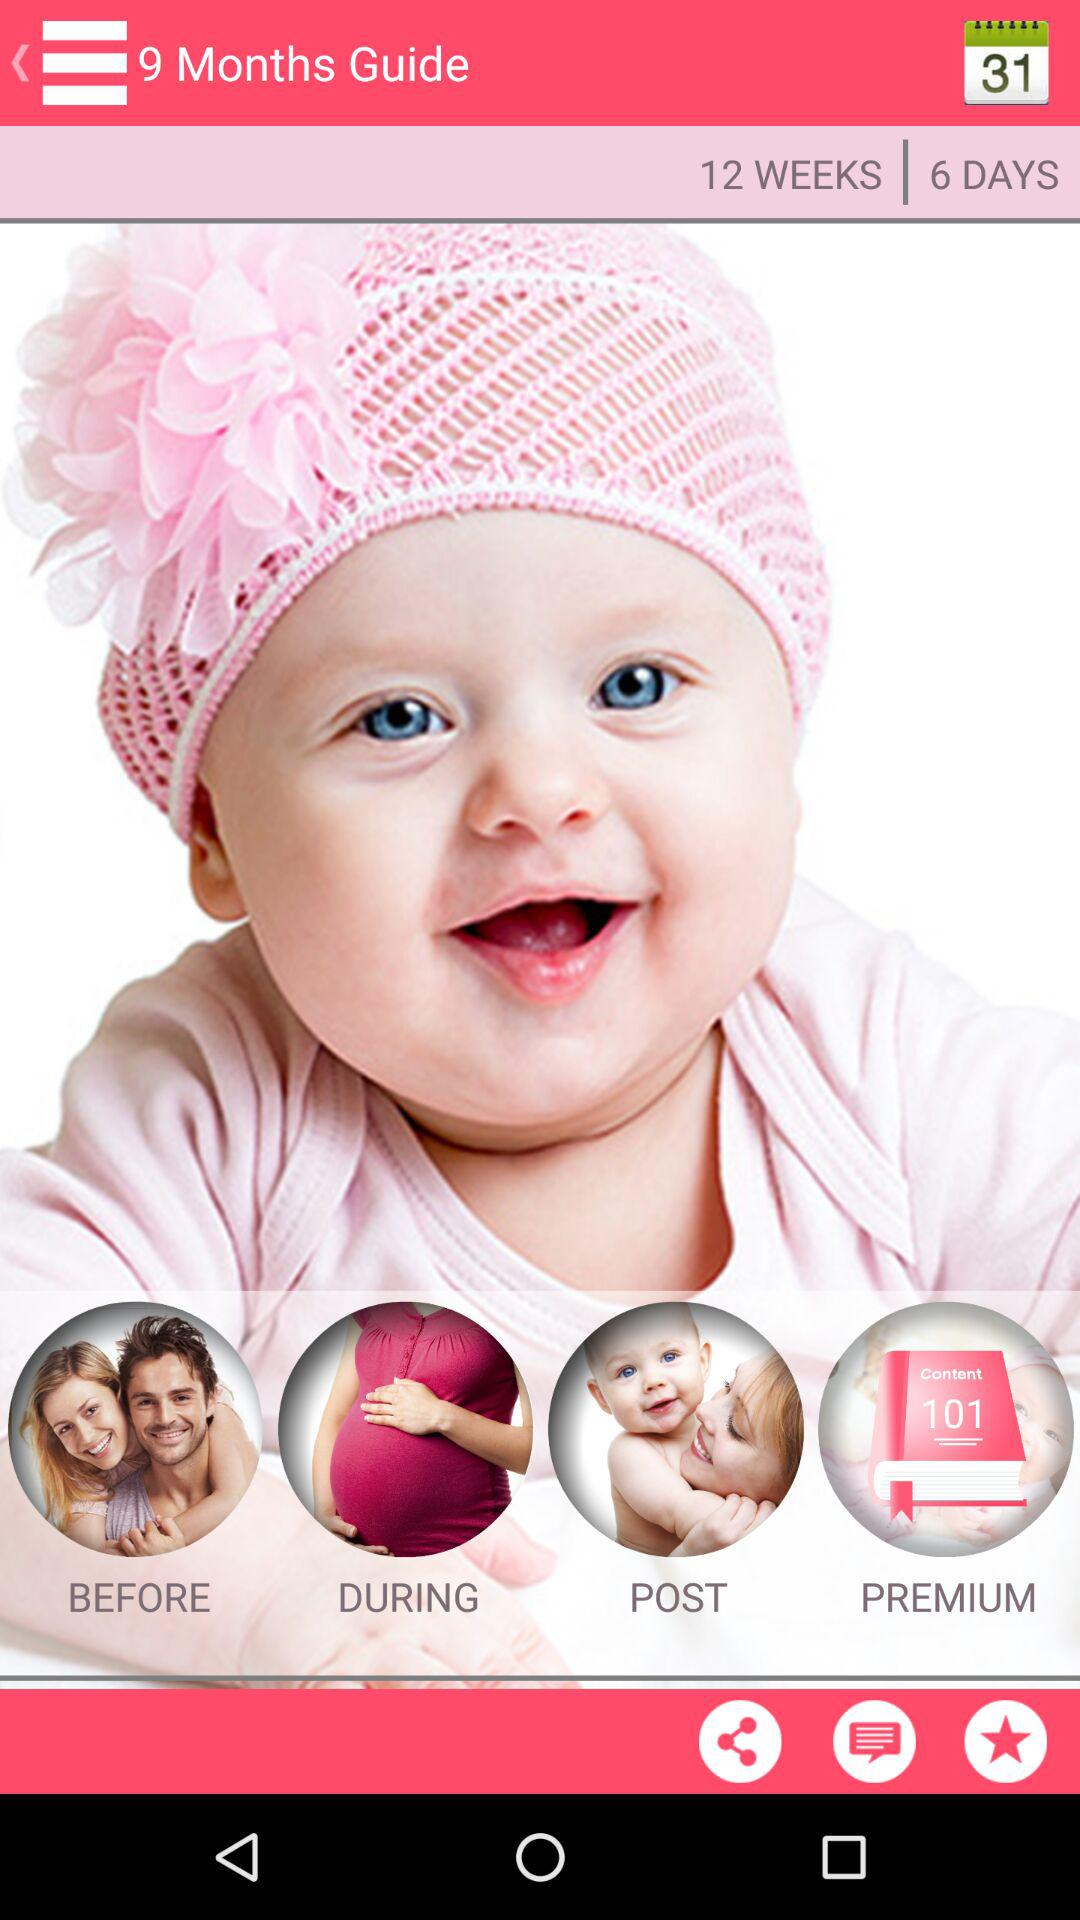What is the date shown in the calendar?
When the provided information is insufficient, respond with <no answer>. <no answer> 